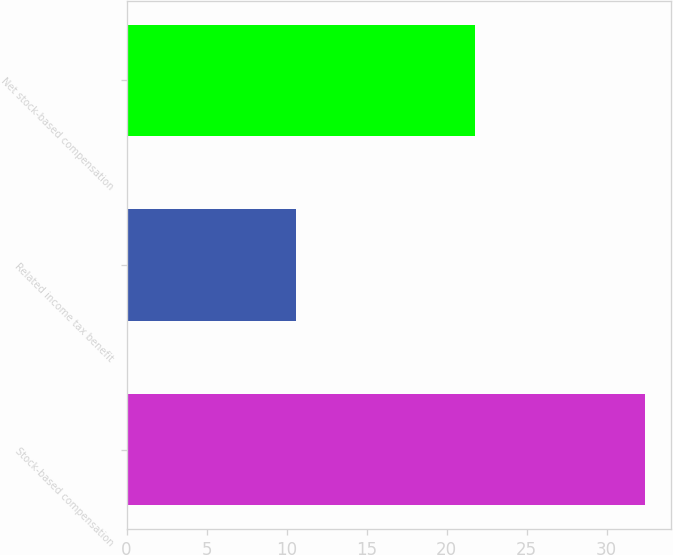<chart> <loc_0><loc_0><loc_500><loc_500><bar_chart><fcel>Stock-based compensation<fcel>Related income tax benefit<fcel>Net stock-based compensation<nl><fcel>32.4<fcel>10.6<fcel>21.8<nl></chart> 